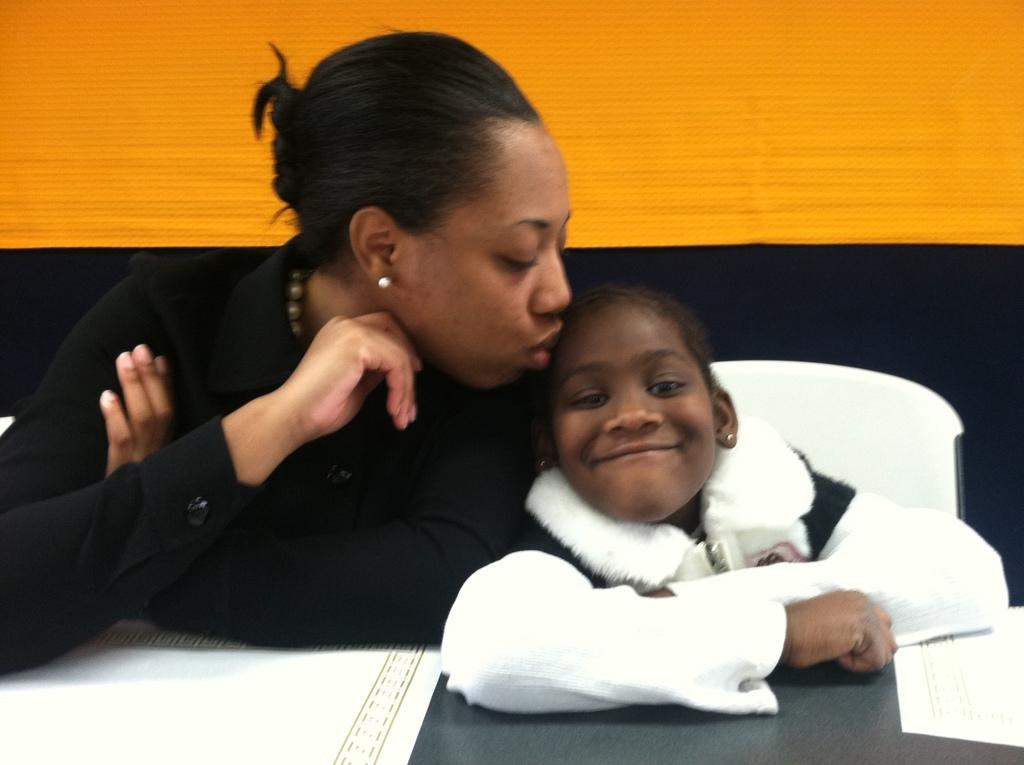Who are the people in the image? There is a woman and a girl sitting in the image. What is the woman doing to the girl? The woman is kissing the girl. What is on the table in the image? There is a table with papers on it in the image. What colors are on the wall in the image? The wall in the image is yellow and black in color. What is the temperature of the woman's thought in the image? There is no mention of temperature or thoughts in the image; it shows a woman kissing a girl. 